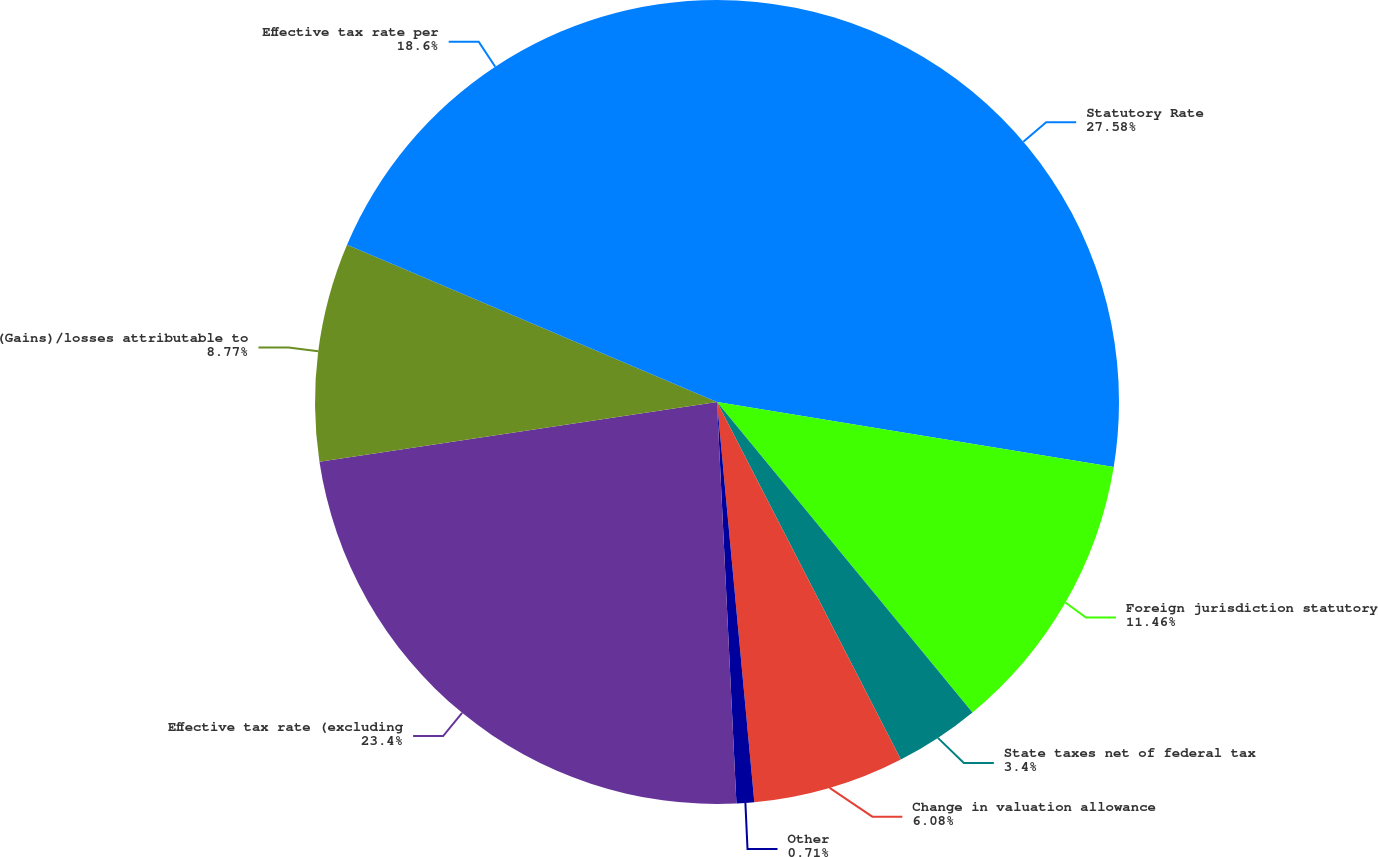Convert chart to OTSL. <chart><loc_0><loc_0><loc_500><loc_500><pie_chart><fcel>Statutory Rate<fcel>Foreign jurisdiction statutory<fcel>State taxes net of federal tax<fcel>Change in valuation allowance<fcel>Other<fcel>Effective tax rate (excluding<fcel>(Gains)/losses attributable to<fcel>Effective tax rate per<nl><fcel>27.58%<fcel>11.46%<fcel>3.4%<fcel>6.08%<fcel>0.71%<fcel>23.4%<fcel>8.77%<fcel>18.6%<nl></chart> 